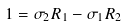<formula> <loc_0><loc_0><loc_500><loc_500>1 = \sigma _ { 2 } R _ { 1 } - \sigma _ { 1 } R _ { 2 }</formula> 